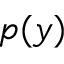<formula> <loc_0><loc_0><loc_500><loc_500>p ( y )</formula> 